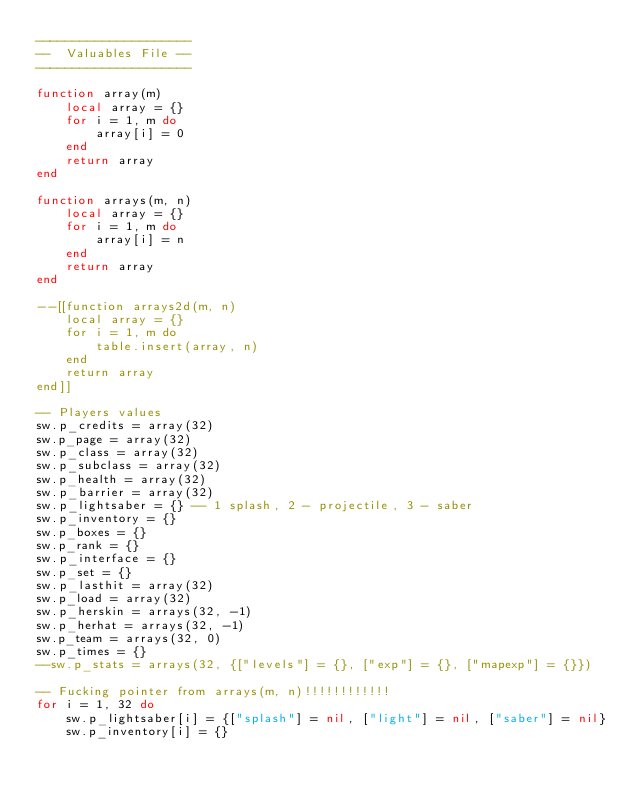<code> <loc_0><loc_0><loc_500><loc_500><_Lua_>---------------------
--  Valuables File --
---------------------

function array(m)
	local array = {}
	for i = 1, m do
		array[i] = 0
	end
	return array
end

function arrays(m, n)
	local array = {}
	for i = 1, m do
		array[i] = n
	end
	return array
end

--[[function arrays2d(m, n)
	local array = {}
	for i = 1, m do
		table.insert(array, n)
	end
	return array
end]]

-- Players values
sw.p_credits = array(32)
sw.p_page = array(32)
sw.p_class = array(32)
sw.p_subclass = array(32)
sw.p_health = array(32)
sw.p_barrier = array(32)
sw.p_lightsaber = {} -- 1 splash, 2 - projectile, 3 - saber
sw.p_inventory = {}
sw.p_boxes = {}
sw.p_rank = {}
sw.p_interface = {}
sw.p_set = {}
sw.p_lasthit = array(32)
sw.p_load = array(32)
sw.p_herskin = arrays(32, -1)
sw.p_herhat = arrays(32, -1)
sw.p_team = arrays(32, 0)
sw.p_times = {}
--sw.p_stats = arrays(32, {["levels"] = {}, ["exp"] = {}, ["mapexp"] = {}})

-- Fucking pointer from arrays(m, n)!!!!!!!!!!!!
for i = 1, 32 do
	sw.p_lightsaber[i] = {["splash"] = nil, ["light"] = nil, ["saber"] = nil}
	sw.p_inventory[i] = {}</code> 